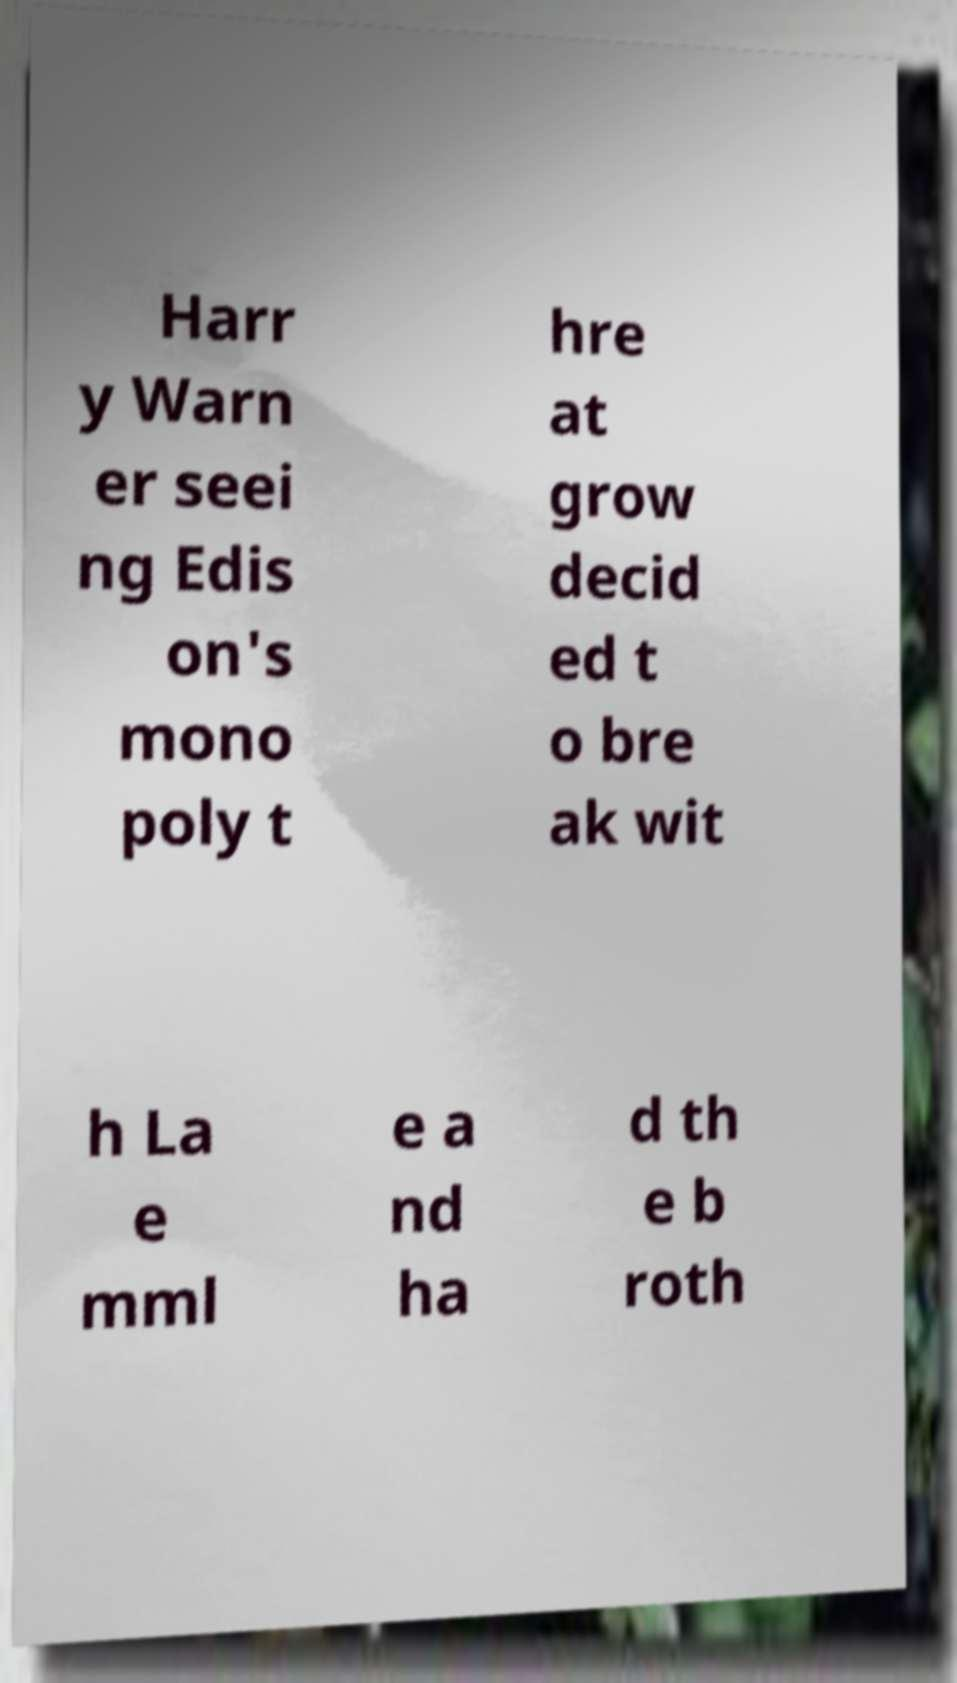For documentation purposes, I need the text within this image transcribed. Could you provide that? Harr y Warn er seei ng Edis on's mono poly t hre at grow decid ed t o bre ak wit h La e mml e a nd ha d th e b roth 